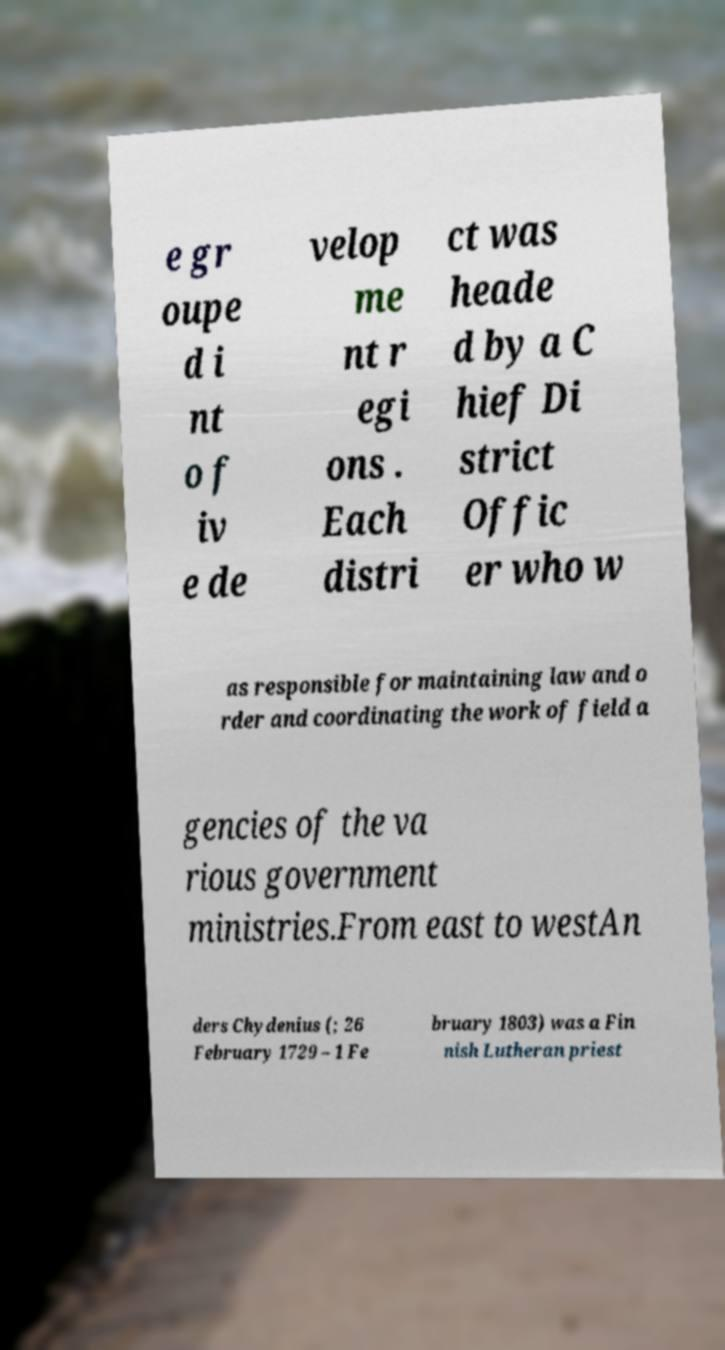Could you assist in decoding the text presented in this image and type it out clearly? e gr oupe d i nt o f iv e de velop me nt r egi ons . Each distri ct was heade d by a C hief Di strict Offic er who w as responsible for maintaining law and o rder and coordinating the work of field a gencies of the va rious government ministries.From east to westAn ders Chydenius (; 26 February 1729 – 1 Fe bruary 1803) was a Fin nish Lutheran priest 